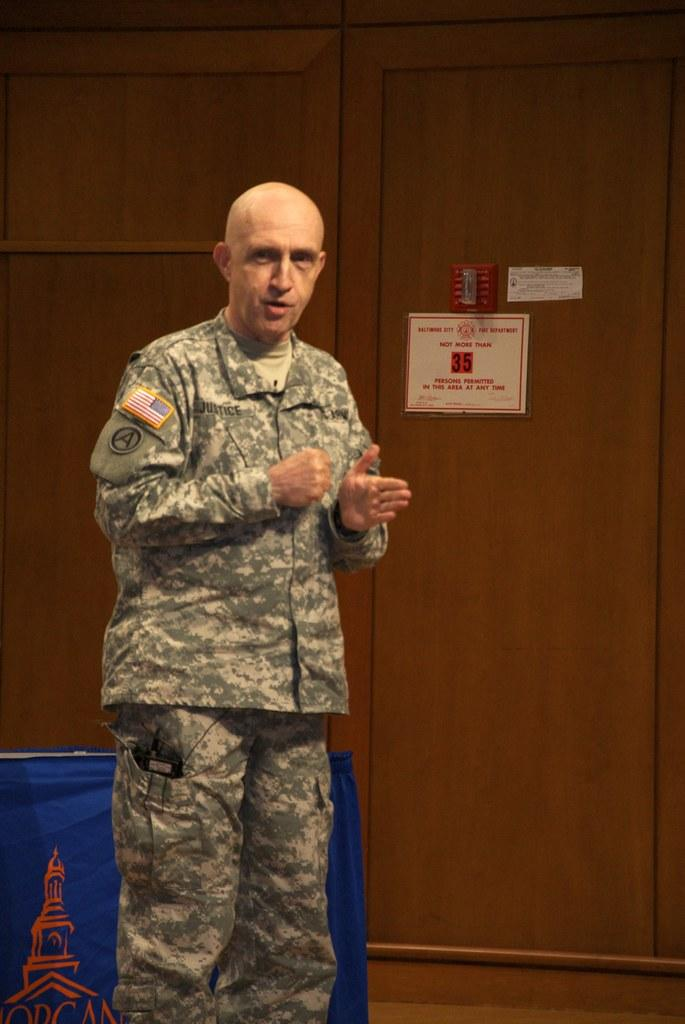Who is present in the image? There is a man in the image. What can be seen in the background of the image? There is a table with a cloth and a wooden wall in the background. What is on the wooden wall? There are posters on the wooden wall. What type of selection does the man have to make in the image? There is no indication in the image that the man has to make any selections. What is the chance of the wooden wall collapsing in the image? The image does not provide any information about the stability of the wooden wall, so it is impossible to determine the chance of it collapsing. 